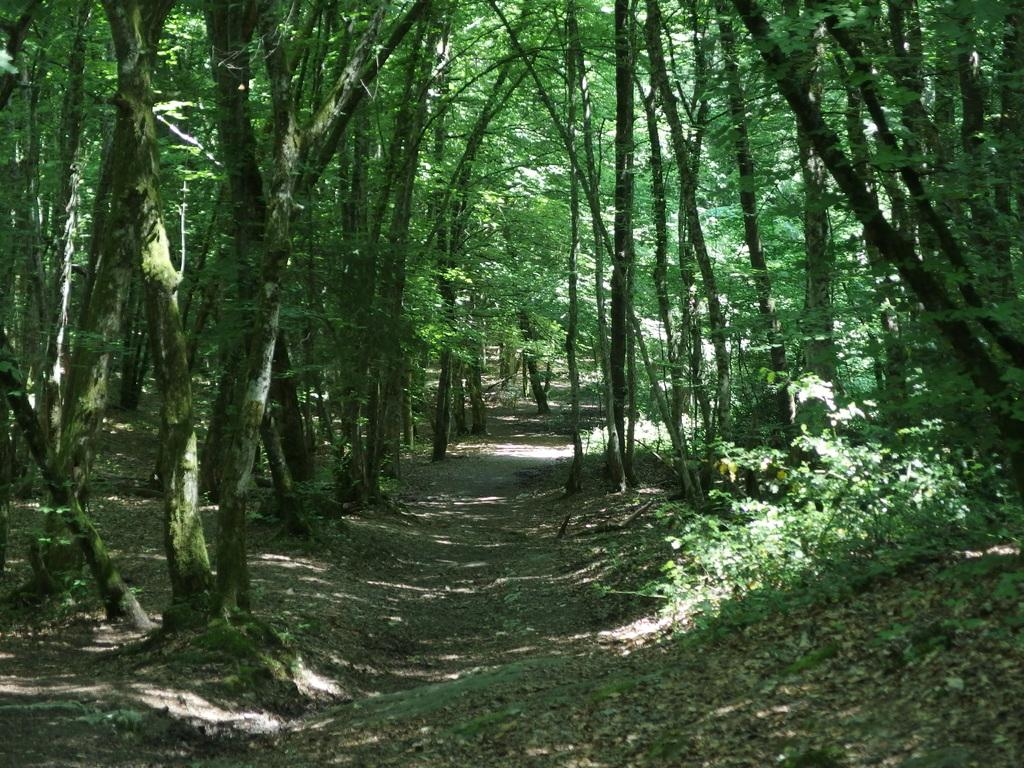What is the main feature in the middle of the image? There is a path in the middle of the image. What can be seen on either side of the path? Trees are present on either side of the path. Where are the trees and path located? The trees and path are on the land. How many worms can be seen crawling on the path in the image? There are no worms present in the image; it only features a path and trees. 